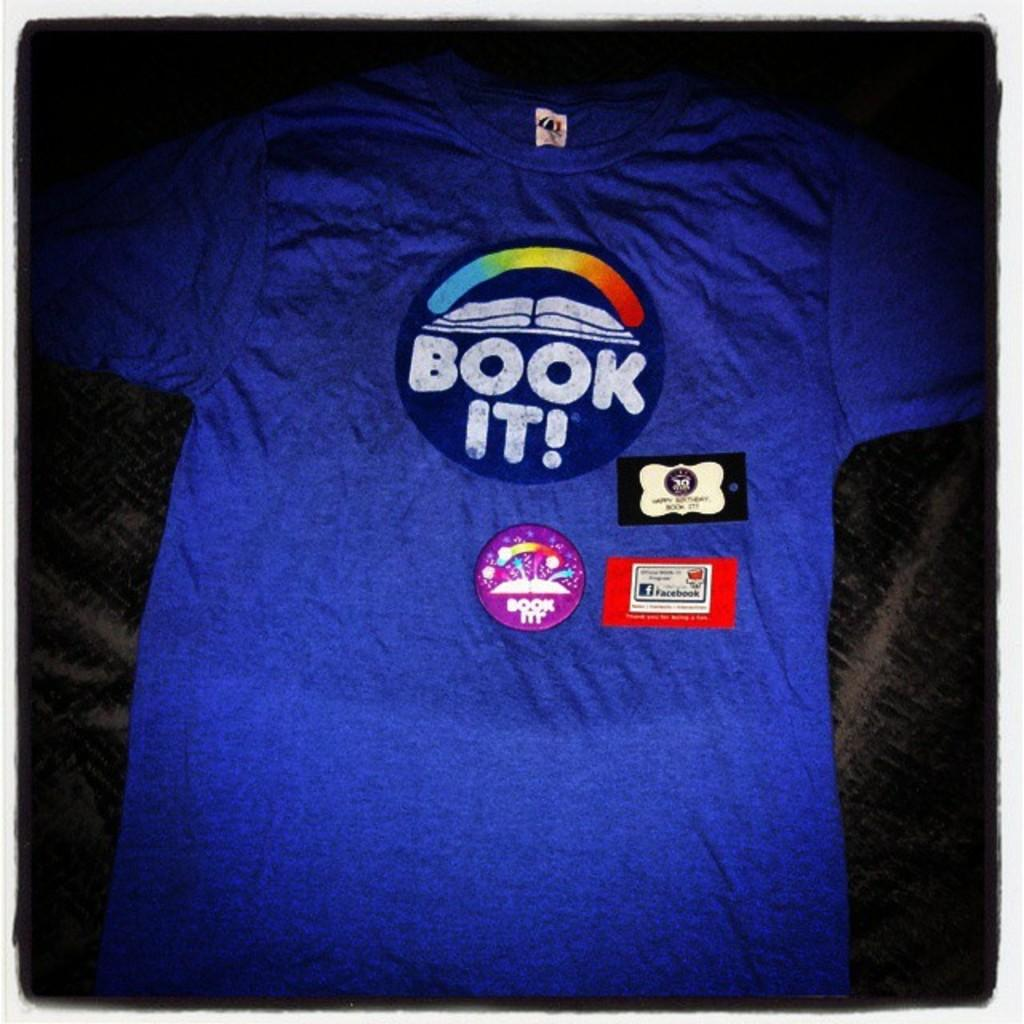<image>
Share a concise interpretation of the image provided. The front of a t shirt has "Book it" under a small rainbow. 